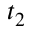Convert formula to latex. <formula><loc_0><loc_0><loc_500><loc_500>t _ { 2 }</formula> 